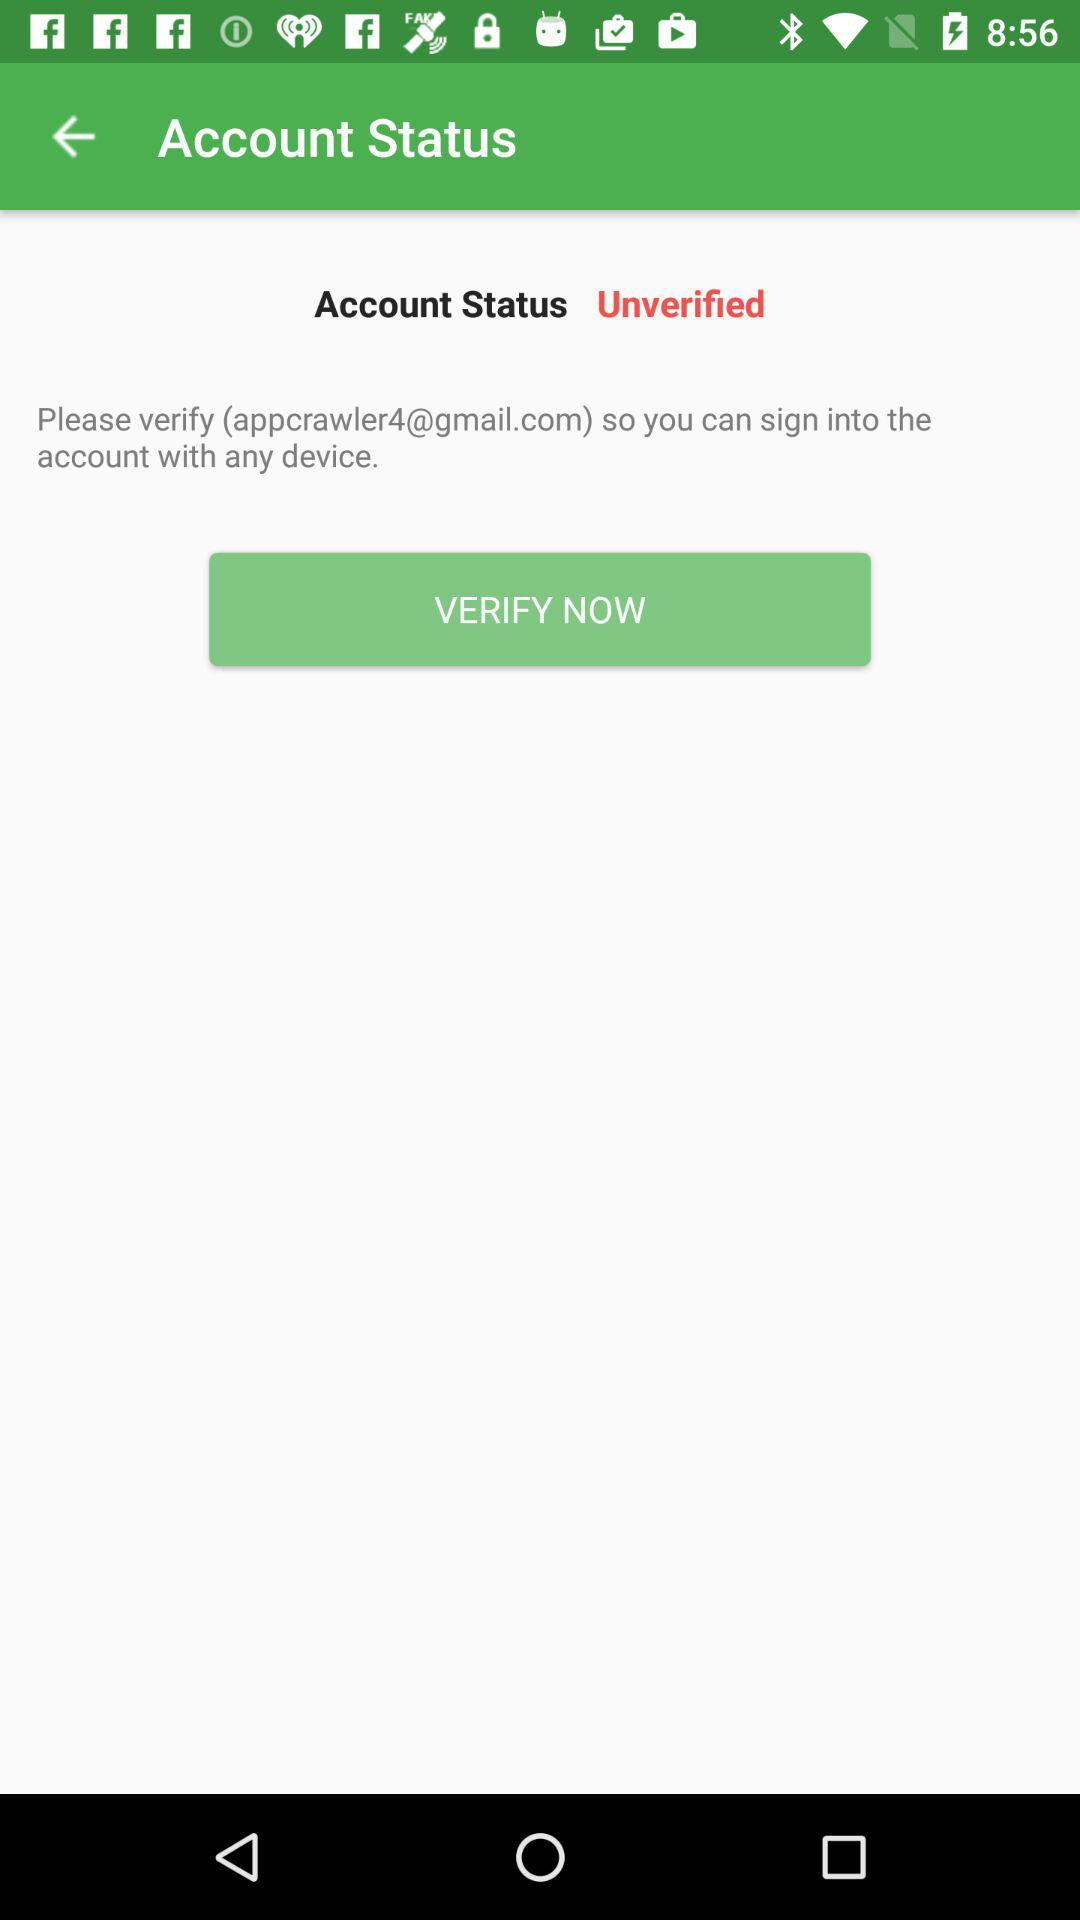What is the user's name?
When the provided information is insufficient, respond with <no answer>. <no answer> 